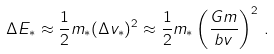Convert formula to latex. <formula><loc_0><loc_0><loc_500><loc_500>\Delta E _ { * } \approx \frac { 1 } { 2 } m _ { * } ( \Delta v _ { * } ) ^ { 2 } \approx \frac { 1 } { 2 } m _ { * } \left ( \frac { G m } { b v } \right ) ^ { 2 } \, .</formula> 